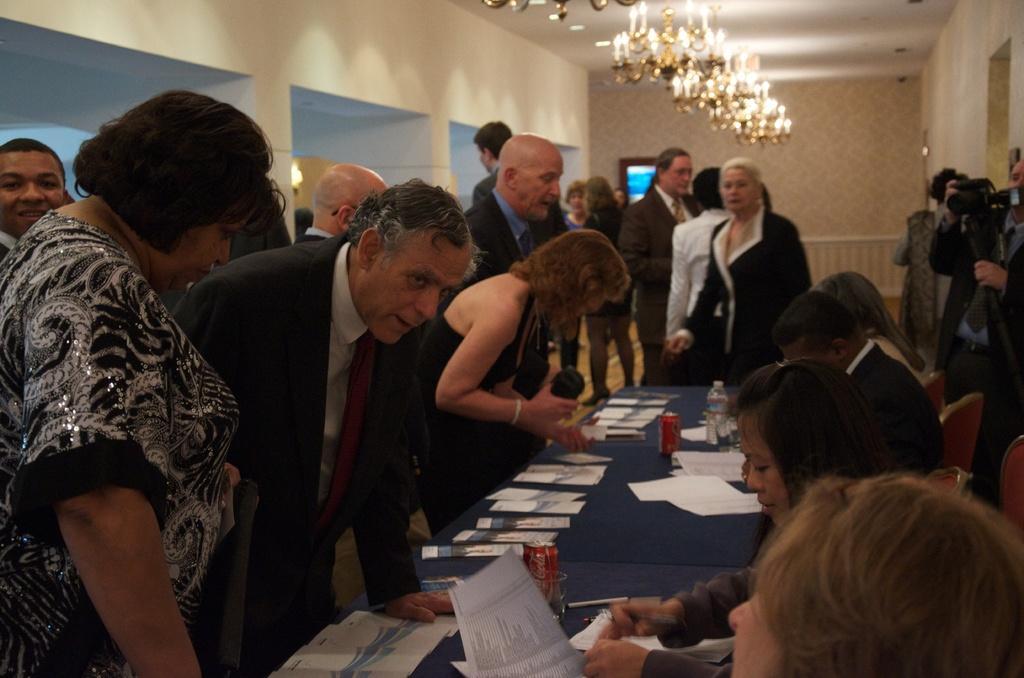Describe this image in one or two sentences. In the middle of the image a group of people standing. Bottom middle of the image there is a table, On the table there is a tin and water bottle and papers. At the top of image there is a roof and lights. Behind the people there is a wall. Right side of the image a person is capturing. Left side of the image a man is smiling. 